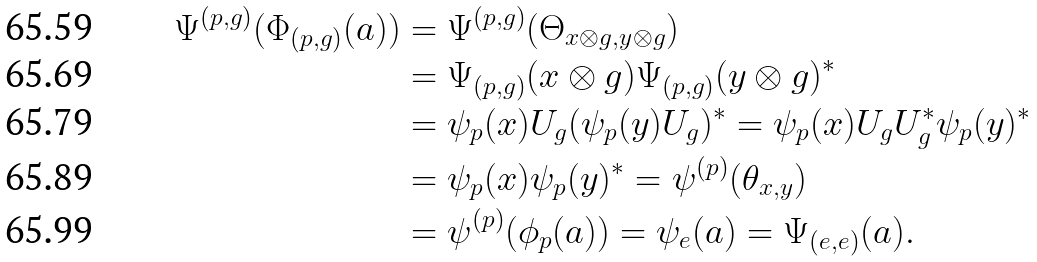<formula> <loc_0><loc_0><loc_500><loc_500>\Psi ^ { ( p , g ) } ( \Phi _ { ( p , g ) } ( a ) ) & = \Psi ^ { ( p , g ) } ( \Theta _ { x \otimes g , y \otimes g } ) \\ & = \Psi _ { ( p , g ) } ( x \otimes g ) \Psi _ { ( p , g ) } ( y \otimes g ) ^ { * } \\ & = \psi _ { p } ( x ) U _ { g } ( \psi _ { p } ( y ) U _ { g } ) ^ { * } = \psi _ { p } ( x ) U _ { g } U _ { g } ^ { * } \psi _ { p } ( y ) ^ { * } \\ & = \psi _ { p } ( x ) \psi _ { p } ( y ) ^ { * } = \psi ^ { ( p ) } ( \theta _ { x , y } ) \\ & = \psi ^ { ( p ) } ( \phi _ { p } ( a ) ) = \psi _ { e } ( a ) = \Psi _ { ( e , e ) } ( a ) .</formula> 